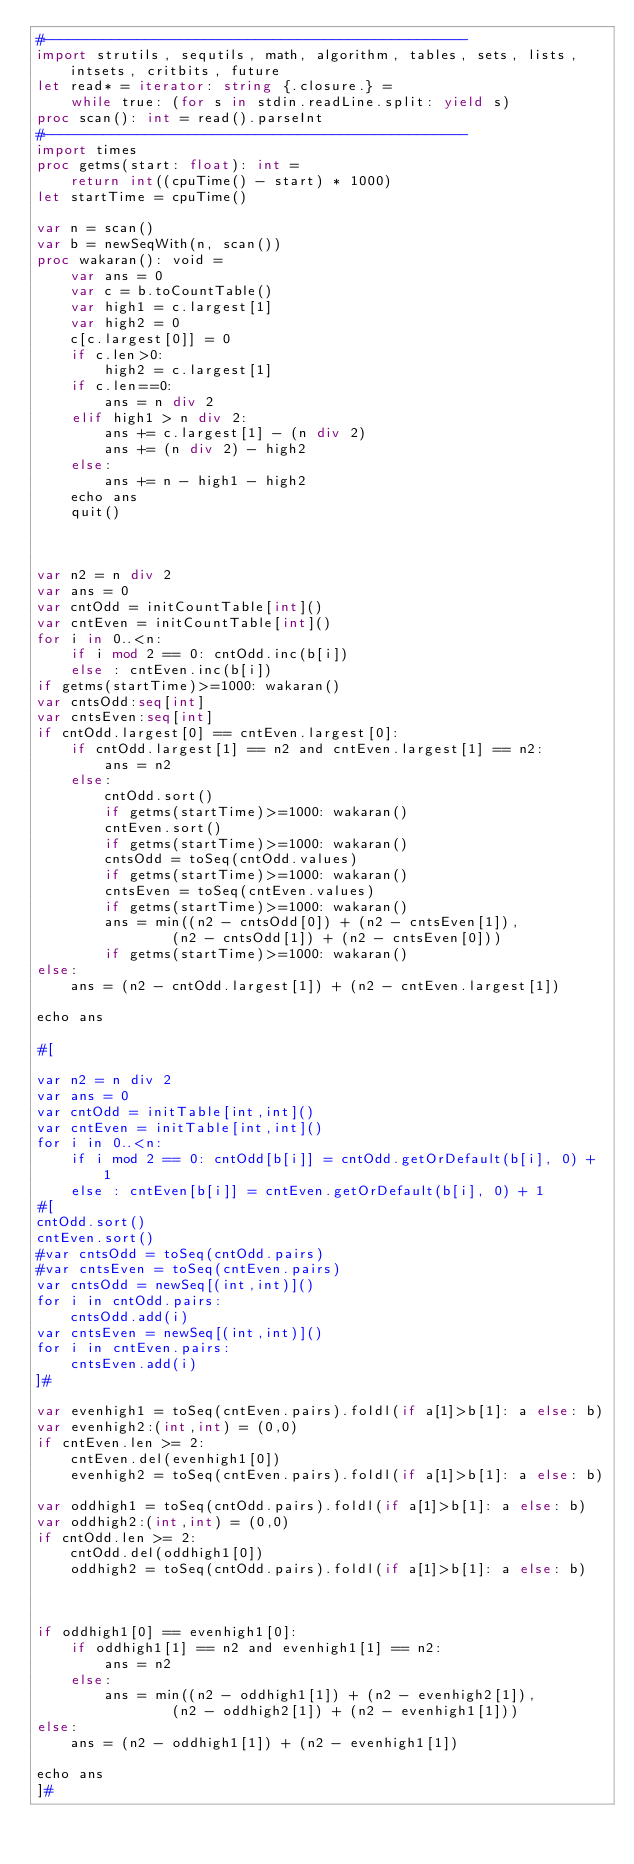Convert code to text. <code><loc_0><loc_0><loc_500><loc_500><_Nim_>#--------------------------------------------------
import strutils, sequtils, math, algorithm, tables, sets, lists, intsets, critbits, future
let read* = iterator: string {.closure.} =
    while true: (for s in stdin.readLine.split: yield s)
proc scan(): int = read().parseInt
#--------------------------------------------------
import times
proc getms(start: float): int =
    return int((cpuTime() - start) * 1000)
let startTime = cpuTime()

var n = scan()
var b = newSeqWith(n, scan())
proc wakaran(): void =
    var ans = 0
    var c = b.toCountTable()
    var high1 = c.largest[1]
    var high2 = 0
    c[c.largest[0]] = 0
    if c.len>0:
        high2 = c.largest[1]
    if c.len==0:
        ans = n div 2
    elif high1 > n div 2:
        ans += c.largest[1] - (n div 2)
        ans += (n div 2) - high2
    else:
        ans += n - high1 - high2
    echo ans
    quit()



var n2 = n div 2
var ans = 0
var cntOdd = initCountTable[int]()
var cntEven = initCountTable[int]()
for i in 0..<n:
    if i mod 2 == 0: cntOdd.inc(b[i])
    else : cntEven.inc(b[i])
if getms(startTime)>=1000: wakaran()
var cntsOdd:seq[int]
var cntsEven:seq[int]
if cntOdd.largest[0] == cntEven.largest[0]:
    if cntOdd.largest[1] == n2 and cntEven.largest[1] == n2:
        ans = n2
    else:
        cntOdd.sort()
        if getms(startTime)>=1000: wakaran()
        cntEven.sort()
        if getms(startTime)>=1000: wakaran()
        cntsOdd = toSeq(cntOdd.values)
        if getms(startTime)>=1000: wakaran()
        cntsEven = toSeq(cntEven.values)
        if getms(startTime)>=1000: wakaran()
        ans = min((n2 - cntsOdd[0]) + (n2 - cntsEven[1]),
                (n2 - cntsOdd[1]) + (n2 - cntsEven[0]))
        if getms(startTime)>=1000: wakaran()
else:
    ans = (n2 - cntOdd.largest[1]) + (n2 - cntEven.largest[1])
 
echo ans

#[

var n2 = n div 2
var ans = 0
var cntOdd = initTable[int,int]()
var cntEven = initTable[int,int]()
for i in 0..<n:
    if i mod 2 == 0: cntOdd[b[i]] = cntOdd.getOrDefault(b[i], 0) + 1
    else : cntEven[b[i]] = cntEven.getOrDefault(b[i], 0) + 1
#[
cntOdd.sort()
cntEven.sort()
#var cntsOdd = toSeq(cntOdd.pairs)
#var cntsEven = toSeq(cntEven.pairs)
var cntsOdd = newSeq[(int,int)]()
for i in cntOdd.pairs:
    cntsOdd.add(i)
var cntsEven = newSeq[(int,int)]()
for i in cntEven.pairs:
    cntsEven.add(i)
]#

var evenhigh1 = toSeq(cntEven.pairs).foldl(if a[1]>b[1]: a else: b)
var evenhigh2:(int,int) = (0,0)
if cntEven.len >= 2:
    cntEven.del(evenhigh1[0])
    evenhigh2 = toSeq(cntEven.pairs).foldl(if a[1]>b[1]: a else: b)

var oddhigh1 = toSeq(cntOdd.pairs).foldl(if a[1]>b[1]: a else: b)
var oddhigh2:(int,int) = (0,0)
if cntOdd.len >= 2:
    cntOdd.del(oddhigh1[0])
    oddhigh2 = toSeq(cntOdd.pairs).foldl(if a[1]>b[1]: a else: b)



if oddhigh1[0] == evenhigh1[0]:
    if oddhigh1[1] == n2 and evenhigh1[1] == n2:
        ans = n2
    else:
        ans = min((n2 - oddhigh1[1]) + (n2 - evenhigh2[1]),
                (n2 - oddhigh2[1]) + (n2 - evenhigh1[1]))
else:
    ans = (n2 - oddhigh1[1]) + (n2 - evenhigh1[1])
 
echo ans
]#</code> 